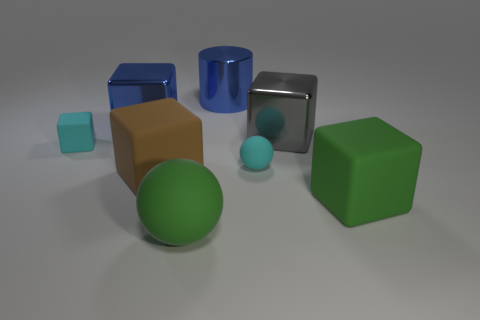Are there more matte cubes behind the blue block than cyan spheres left of the big blue shiny cylinder?
Provide a succinct answer. No. There is a gray object that is the same size as the brown rubber object; what is its material?
Offer a very short reply. Metal. The big brown matte object is what shape?
Offer a terse response. Cube. How many brown objects are either big matte balls or metal cubes?
Give a very brief answer. 0. What size is the green thing that is the same material as the large green sphere?
Your answer should be compact. Large. Is the small cyan thing that is on the right side of the cyan matte cube made of the same material as the big green thing that is to the right of the large gray shiny thing?
Provide a short and direct response. Yes. What number of cylinders are large brown things or tiny objects?
Make the answer very short. 0. What number of green blocks are on the left side of the tiny cyan rubber object on the right side of the cyan matte cube that is to the left of the big blue cylinder?
Offer a terse response. 0. There is a big green thing that is the same shape as the brown rubber object; what material is it?
Your answer should be very brief. Rubber. Are there any other things that are made of the same material as the brown object?
Your answer should be very brief. Yes. 